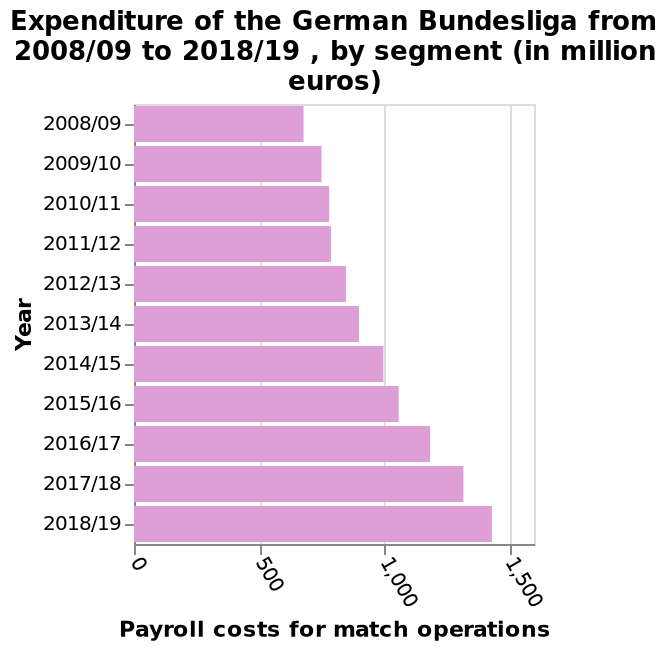<image>
How many years of data are represented in the bar graph? The bar graph represents data from 2008/09 to 2018/19, covering a total of 11 years. Describe the following image in detail This bar graph is titled Expenditure of the German Bundesliga from 2008/09 to 2018/19 , by segment (in million euros). Along the x-axis, Payroll costs for match operations is plotted along a linear scale from 0 to 1,500. The y-axis plots Year. What does the bar graph titled "Expenditure of the German Bundesliga from 2008/09 to 2018/19, by segment" depict?  The bar graph depicts the expenditure of the German Bundesliga from 2008/09 to 2018/19, categorized by segments. Has the expenditure in the German Bundesliga been consistently increasing over the years? Yes, the expenditure in the German Bundesliga has been consistently increasing from 2008 until 2019. 